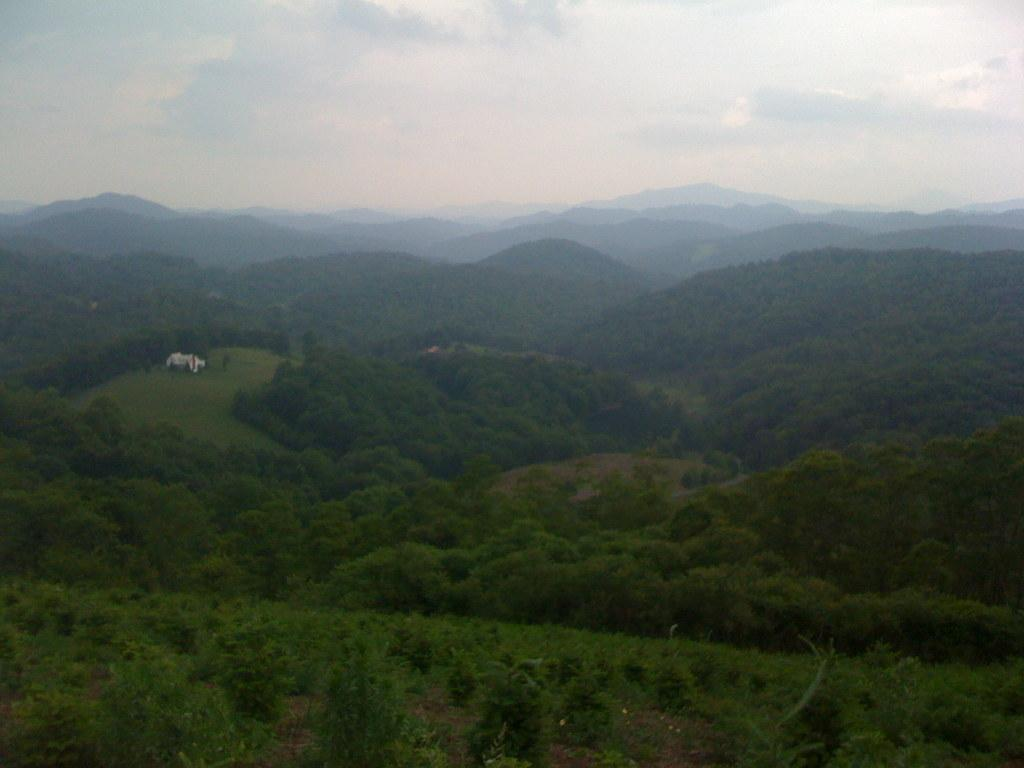What type of natural landform can be seen in the image? There are mountains in the image. What type of vegetation is present in the image? There are trees in the image. What part of the natural environment is visible in the image? The sky is visible in the background of the image. What type of vest is being worn by the mountain in the image? There is no vest present in the image, as the subject is a mountain and not a person. What emotion can be observed on the trees in the image? Trees do not have emotions, so it is not possible to determine what emotion they might be expressing. 